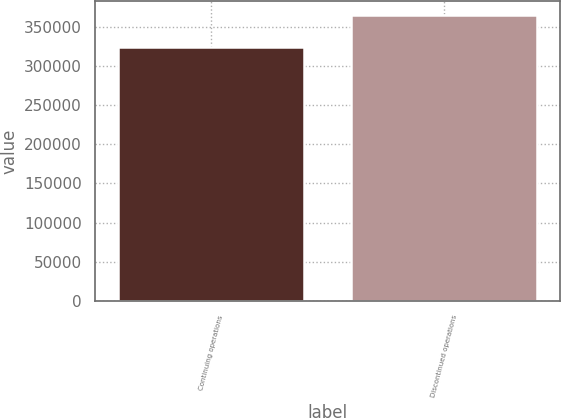<chart> <loc_0><loc_0><loc_500><loc_500><bar_chart><fcel>Continuing operations<fcel>Discontinued operations<nl><fcel>323859<fcel>364856<nl></chart> 